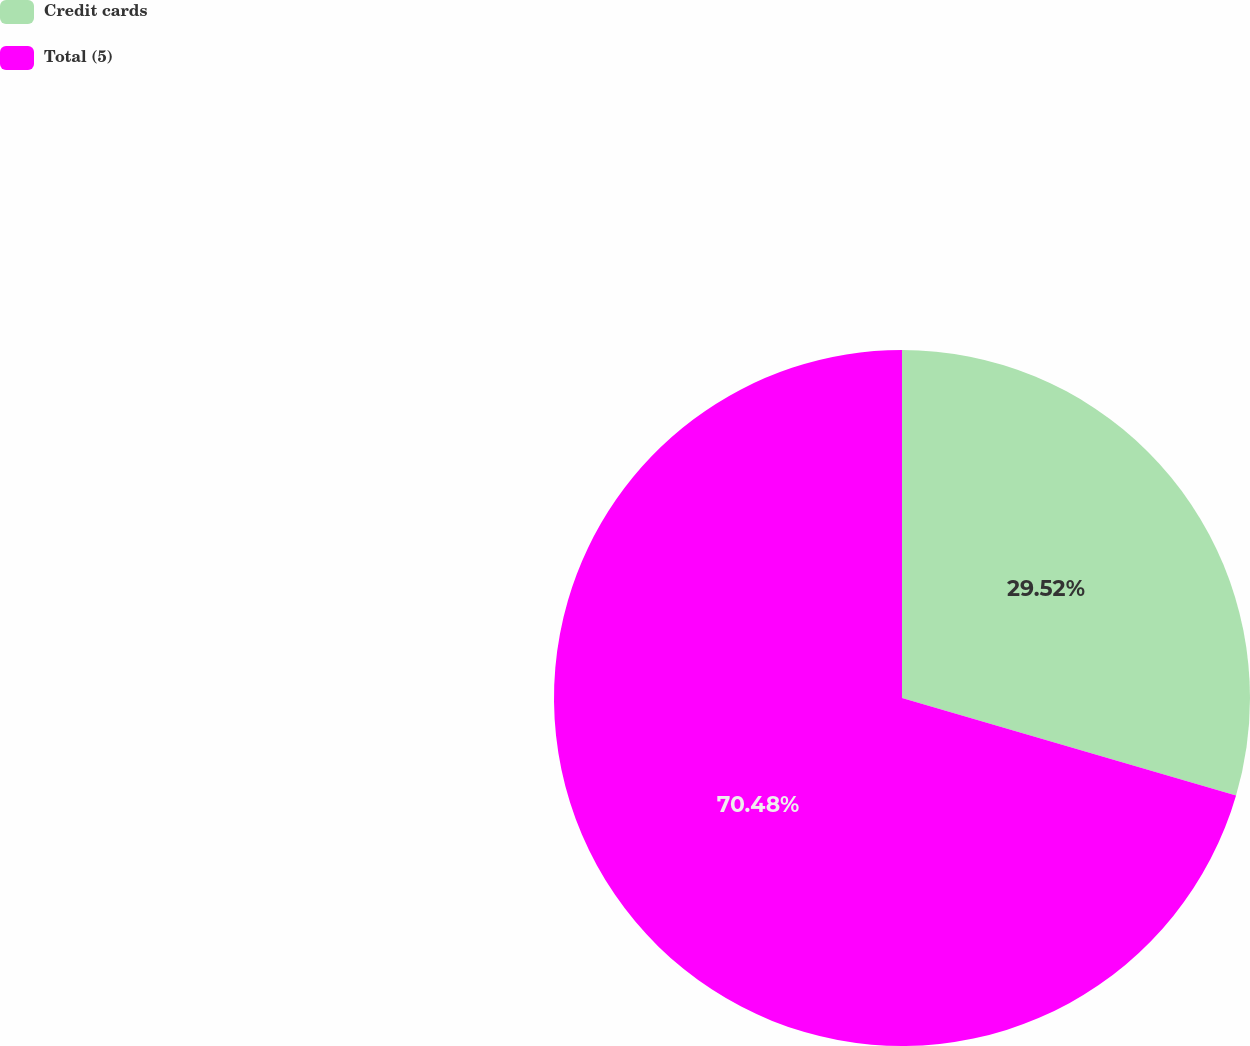Convert chart to OTSL. <chart><loc_0><loc_0><loc_500><loc_500><pie_chart><fcel>Credit cards<fcel>Total (5)<nl><fcel>29.52%<fcel>70.48%<nl></chart> 